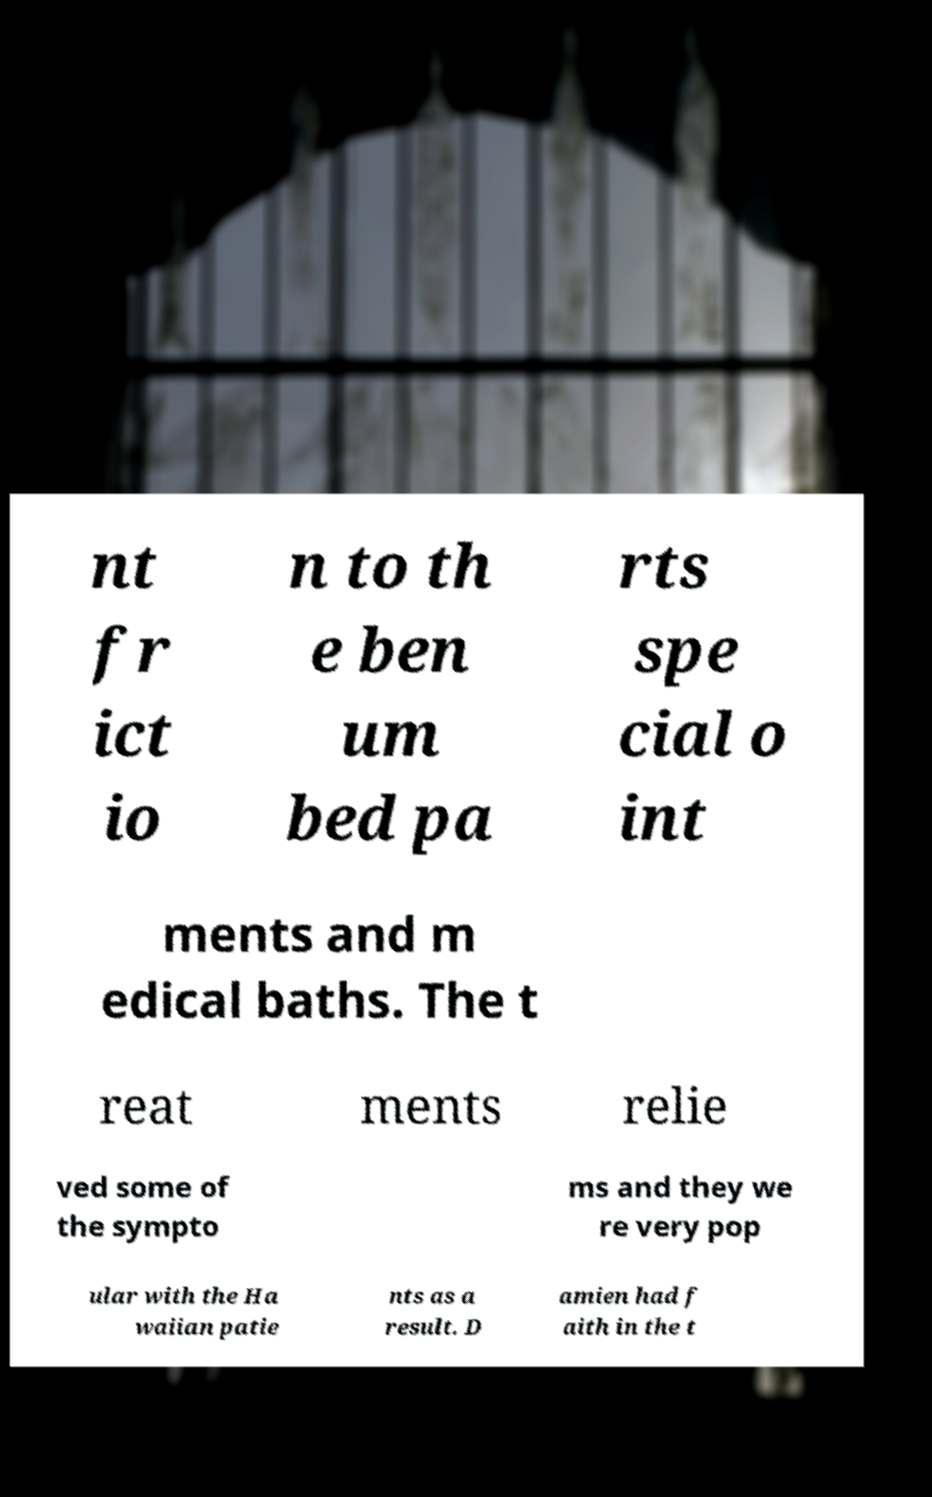Please read and relay the text visible in this image. What does it say? nt fr ict io n to th e ben um bed pa rts spe cial o int ments and m edical baths. The t reat ments relie ved some of the sympto ms and they we re very pop ular with the Ha waiian patie nts as a result. D amien had f aith in the t 